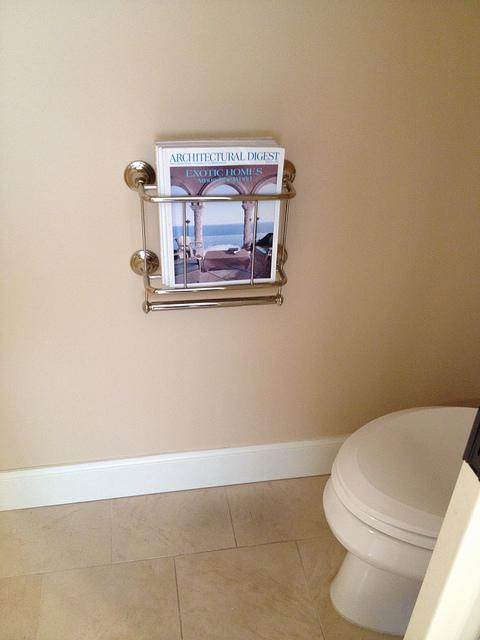What color are the tiles?
Answer briefly. Beige. How many magazines are in the rack?
Short answer required. 1. How many items are on the wall?
Concise answer only. 1. Is this a book or magazine?
Short answer required. Book. Is this a bathroom?
Answer briefly. Yes. 